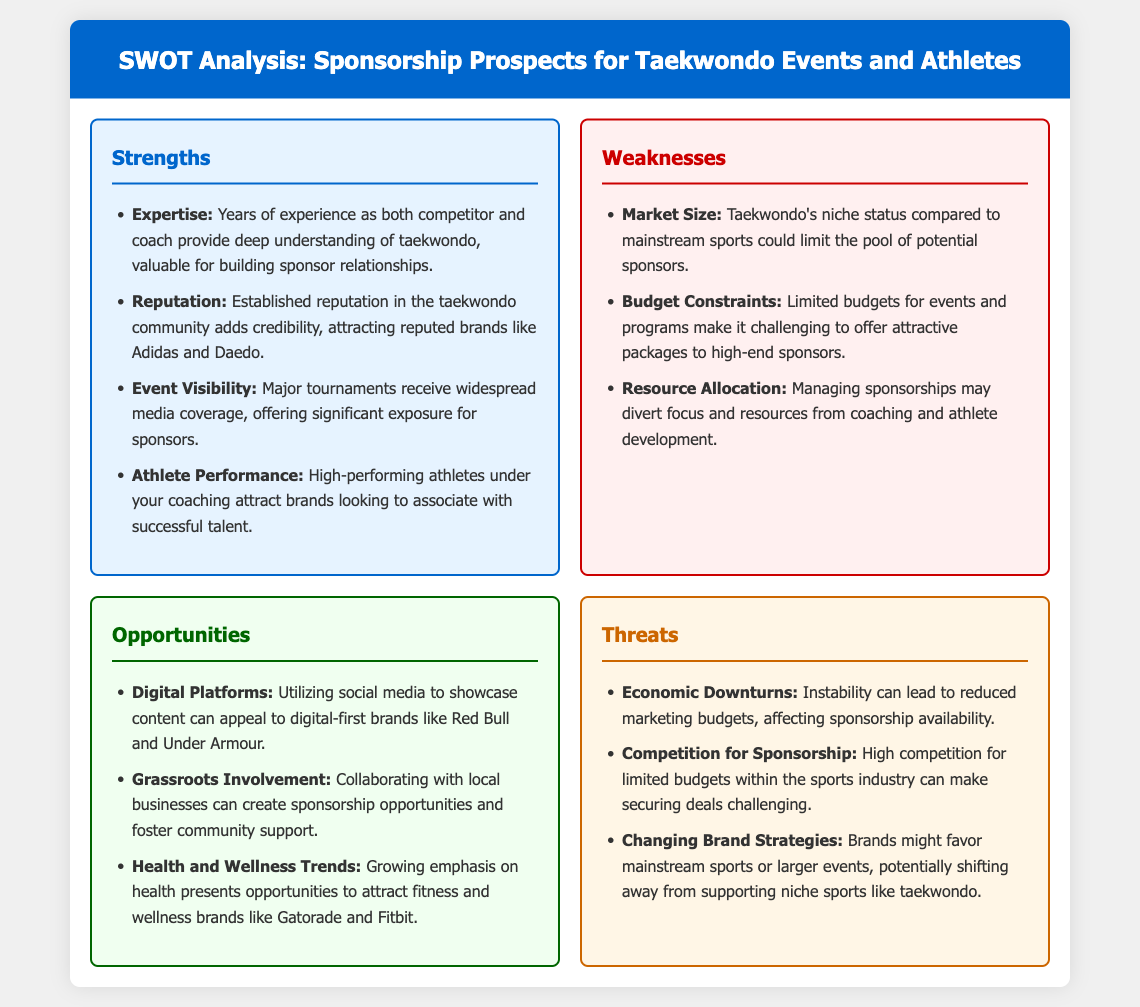What is one of the strengths listed in the analysis? The strengths highlight several key points, one of which is "Expertise."
Answer: Expertise Which brand is mentioned as a notable potential sponsor? The document lists reputable brands like Adidas and Daedo as potential sponsors.
Answer: Adidas What is a weakness identified regarding the sport's market? The analysis points out "Market Size" as a weakness, indicating its niche status compared to mainstream sports.
Answer: Market Size How can digital platforms be used according to the opportunities? The opportunities section suggests utilizing social media to appeal to digital-first brands.
Answer: Social media What economic factor poses a threat to sponsorship prospects? The document mentions "Economic Downturns" as a factor that can affect sponsorship availability.
Answer: Economic Downturns Which trend is mentioned as an opportunity for attracting sponsorship? The opportunities include "Health and Wellness Trends," indicating a growing emphasis on fitness.
Answer: Health and Wellness Trends What may divert focus and resources from coaching? The analysis mentions "Resource Allocation" as a potential issue in managing sponsorships.
Answer: Resource Allocation Which industry challenge is highlighted concerning sponsorship competition? The document indicates "Competition for Sponsorship" as a challenge, noting high competition for limited budgets.
Answer: Competition for Sponsorship 